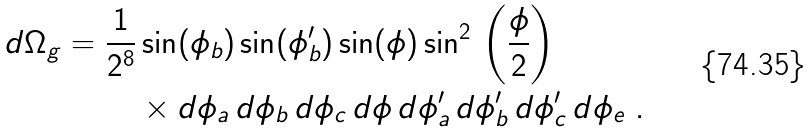<formula> <loc_0><loc_0><loc_500><loc_500>d \Omega _ { g } = \frac { 1 } { 2 ^ { 8 } } & \sin ( \phi _ { b } ) \sin ( \phi ^ { \prime } _ { b } ) \sin ( \phi ) \sin ^ { 2 } \, \left ( \frac { \phi } { 2 } \right ) \\ & \times d \phi _ { a } \, d \phi _ { b } \, d \phi _ { c } \, d \phi \, d \phi ^ { \prime } _ { a } \, d \phi ^ { \prime } _ { b } \, d \phi ^ { \prime } _ { c } \, d \phi _ { e } \ .</formula> 